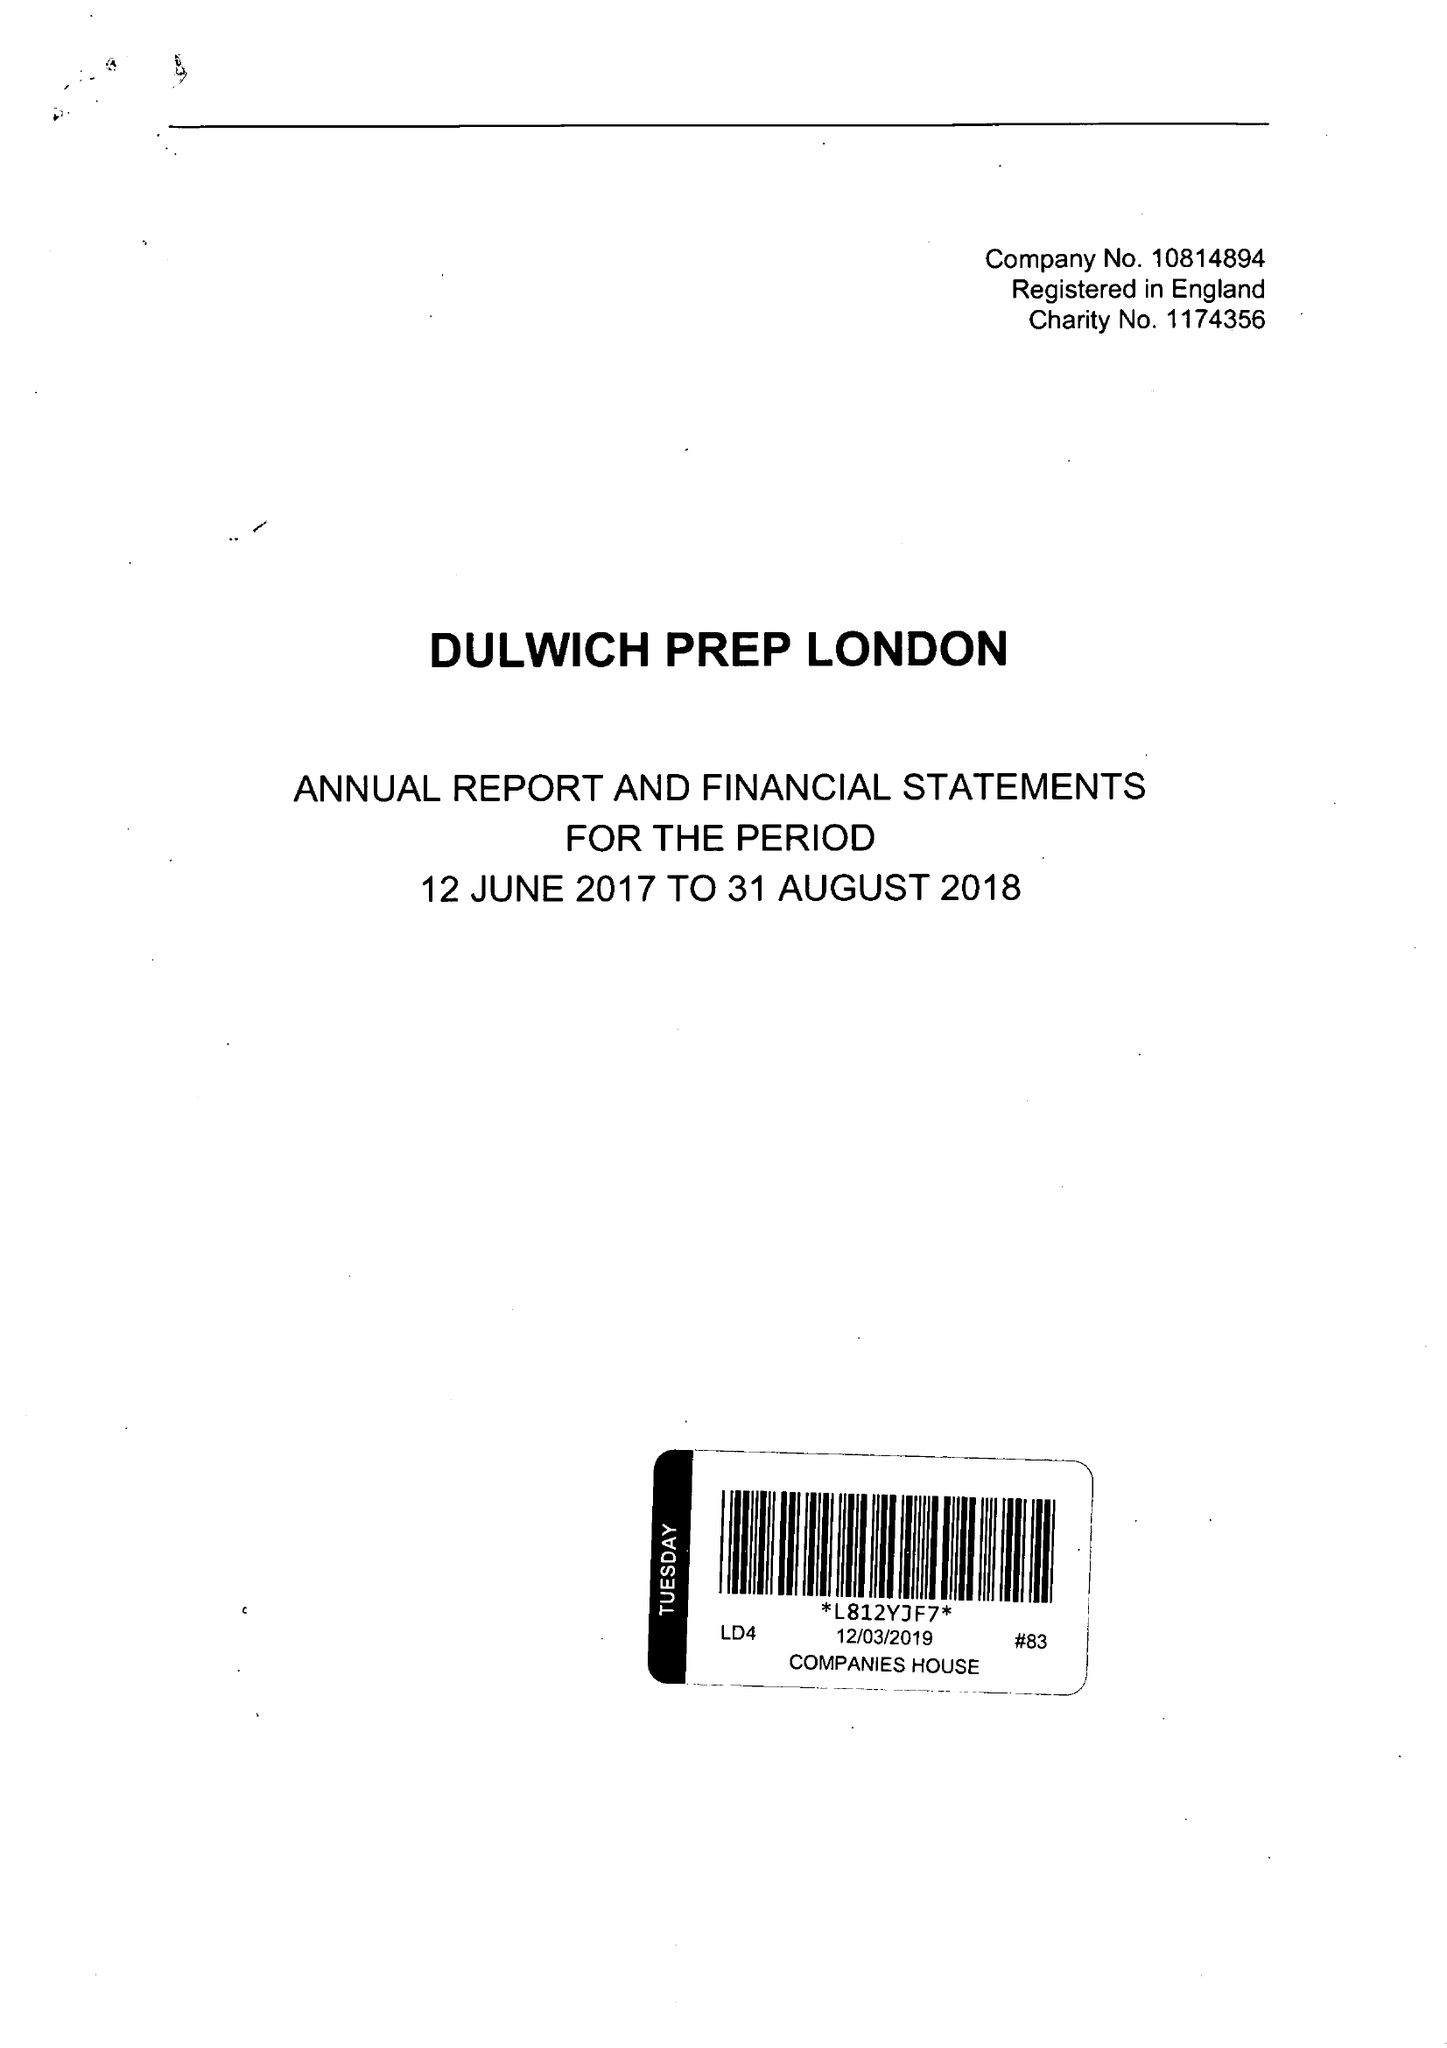What is the value for the spending_annually_in_british_pounds?
Answer the question using a single word or phrase. 13868313.00 